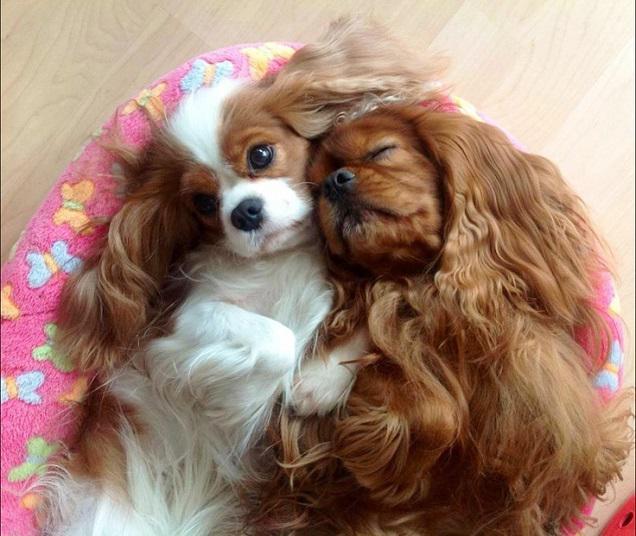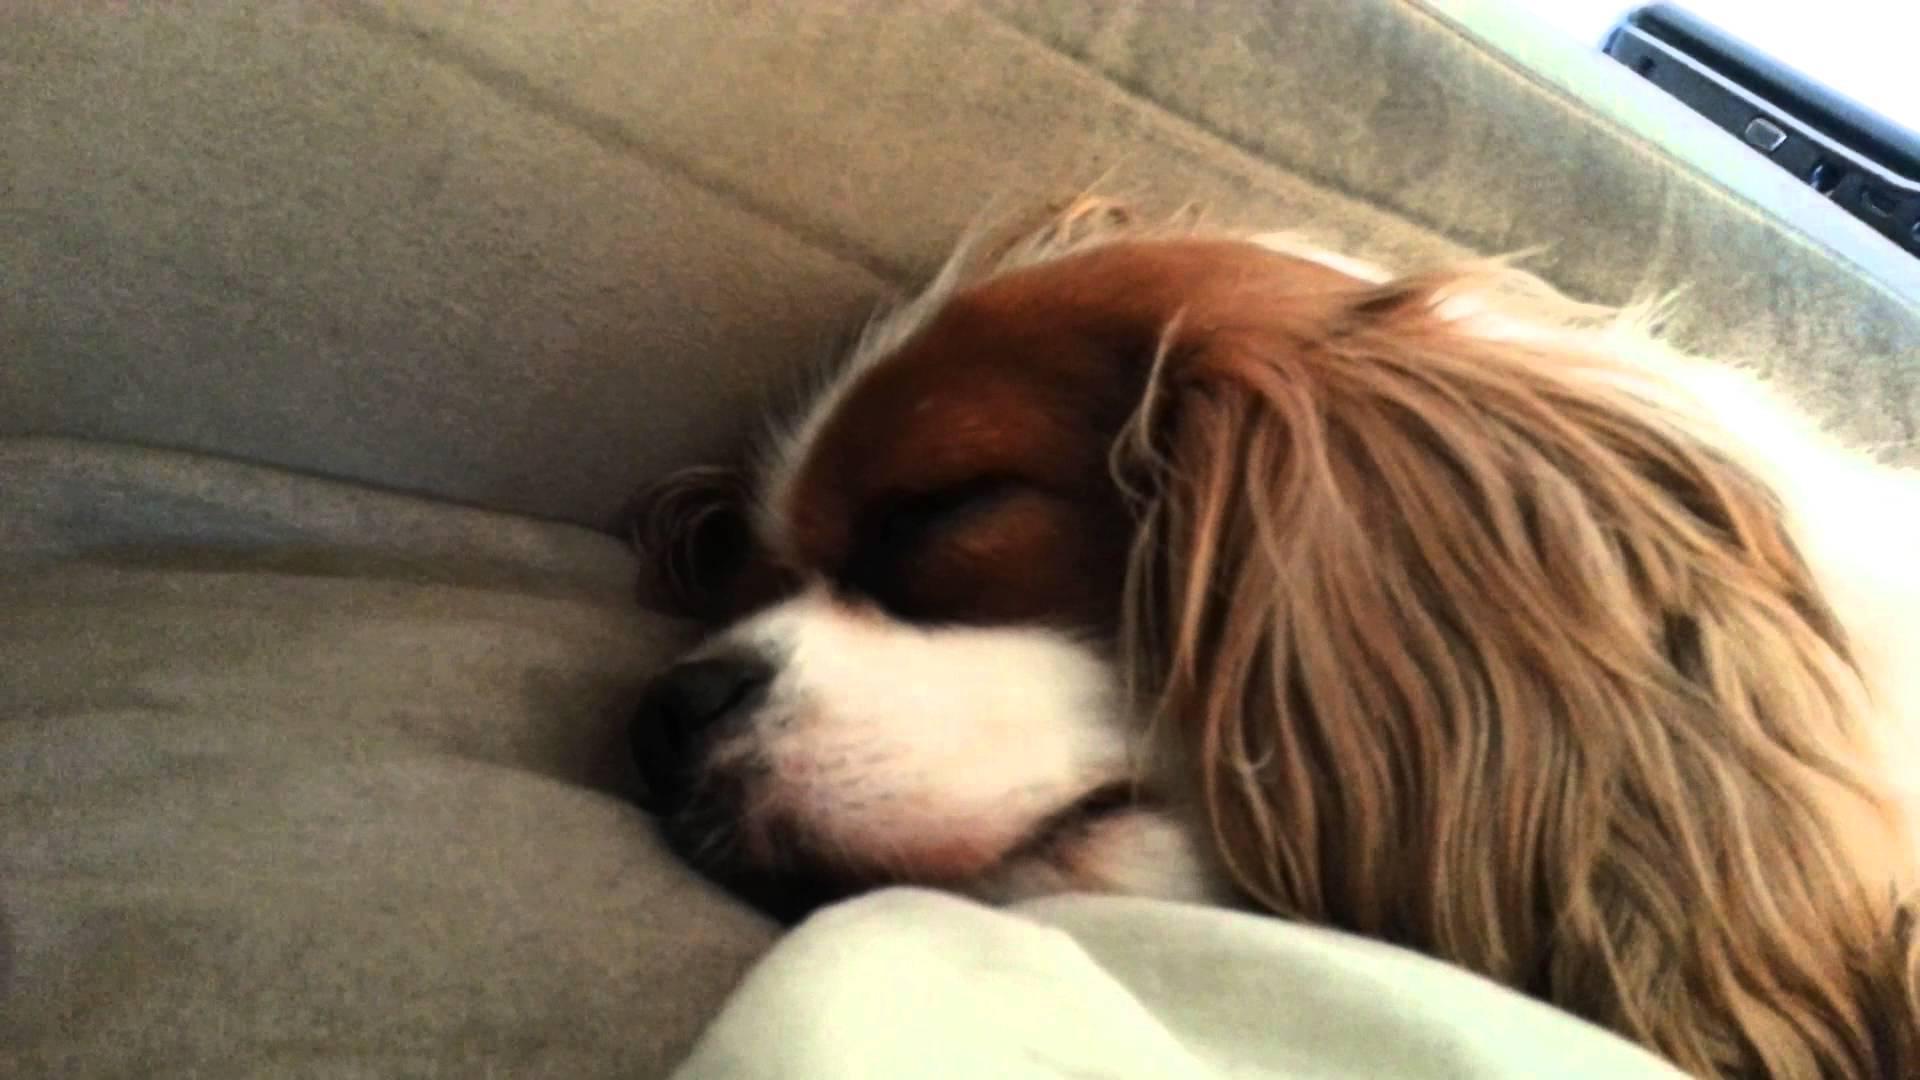The first image is the image on the left, the second image is the image on the right. Considering the images on both sides, is "One image shows a trio of reclining puppies, with the middle one flanked by two dogs with matching coloring." valid? Answer yes or no. No. The first image is the image on the left, the second image is the image on the right. Examine the images to the left and right. Is the description "There are more dogs in the image on the left than in the image on the right." accurate? Answer yes or no. Yes. 